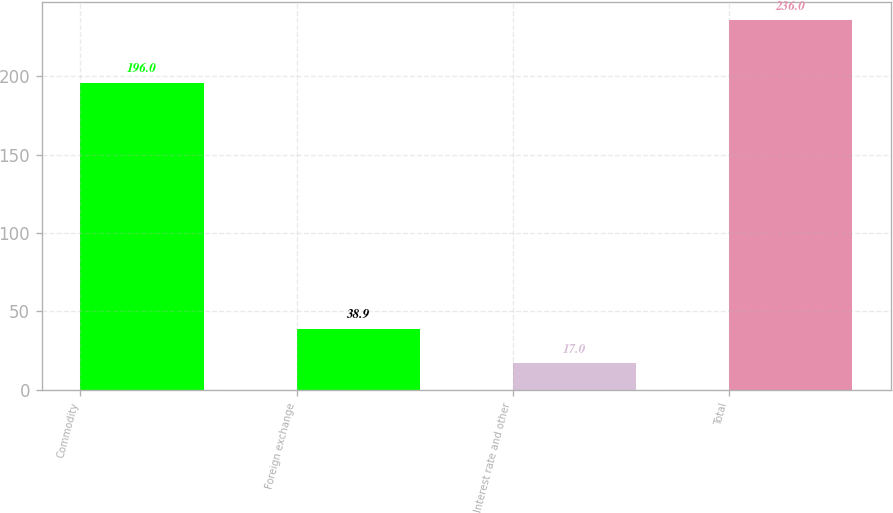Convert chart to OTSL. <chart><loc_0><loc_0><loc_500><loc_500><bar_chart><fcel>Commodity<fcel>Foreign exchange<fcel>Interest rate and other<fcel>Total<nl><fcel>196<fcel>38.9<fcel>17<fcel>236<nl></chart> 